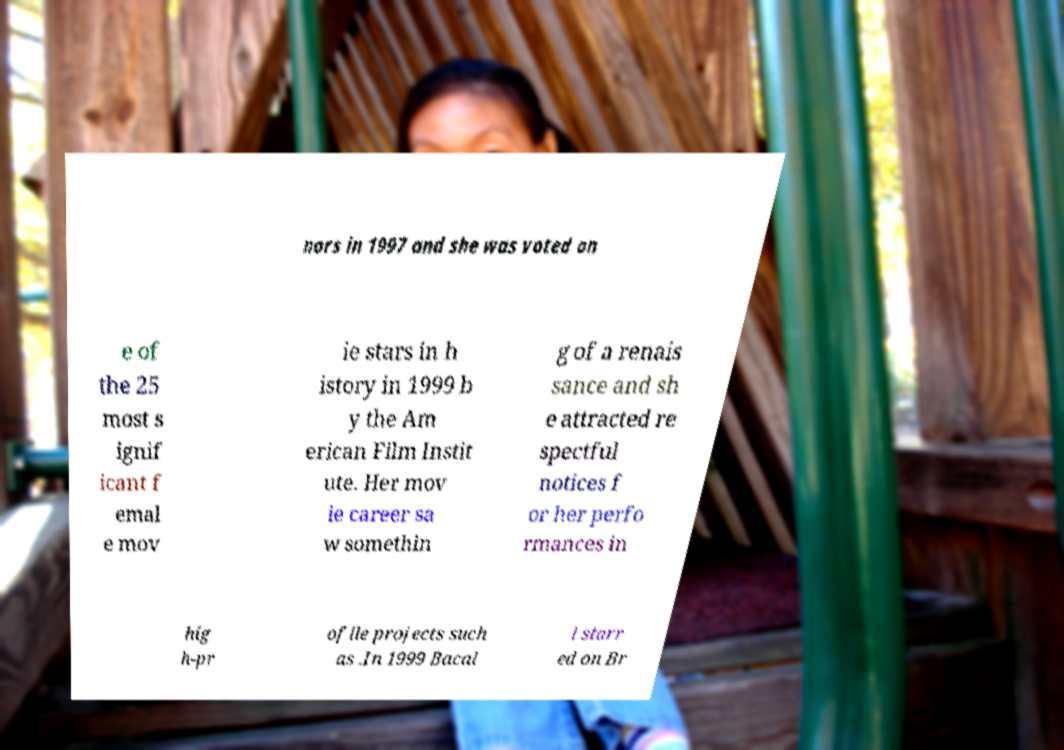Could you extract and type out the text from this image? nors in 1997 and she was voted on e of the 25 most s ignif icant f emal e mov ie stars in h istory in 1999 b y the Am erican Film Instit ute. Her mov ie career sa w somethin g of a renais sance and sh e attracted re spectful notices f or her perfo rmances in hig h-pr ofile projects such as .In 1999 Bacal l starr ed on Br 